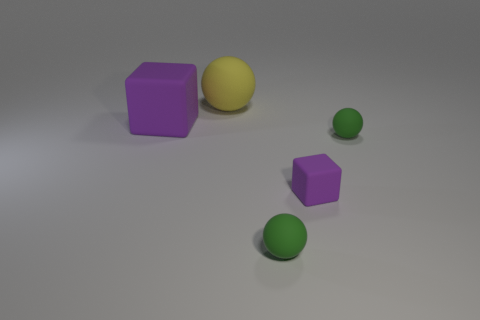How many other objects are the same material as the large ball?
Your answer should be compact. 4. What number of matte objects are cyan objects or green balls?
Your response must be concise. 2. How many objects are purple matte blocks or purple rubber cylinders?
Provide a succinct answer. 2. What is the shape of the other large object that is made of the same material as the large purple thing?
Ensure brevity in your answer.  Sphere. How many tiny things are either green rubber spheres or purple metal cylinders?
Keep it short and to the point. 2. What number of other things are there of the same color as the large ball?
Offer a very short reply. 0. There is a small green matte ball behind the block that is on the right side of the yellow matte sphere; what number of cubes are left of it?
Keep it short and to the point. 2. There is a purple thing to the left of the yellow ball; is its size the same as the large matte sphere?
Provide a succinct answer. Yes. Is the number of small objects that are on the right side of the small purple matte block less than the number of purple cubes that are left of the yellow sphere?
Your response must be concise. No. Does the large ball have the same color as the small rubber block?
Ensure brevity in your answer.  No. 